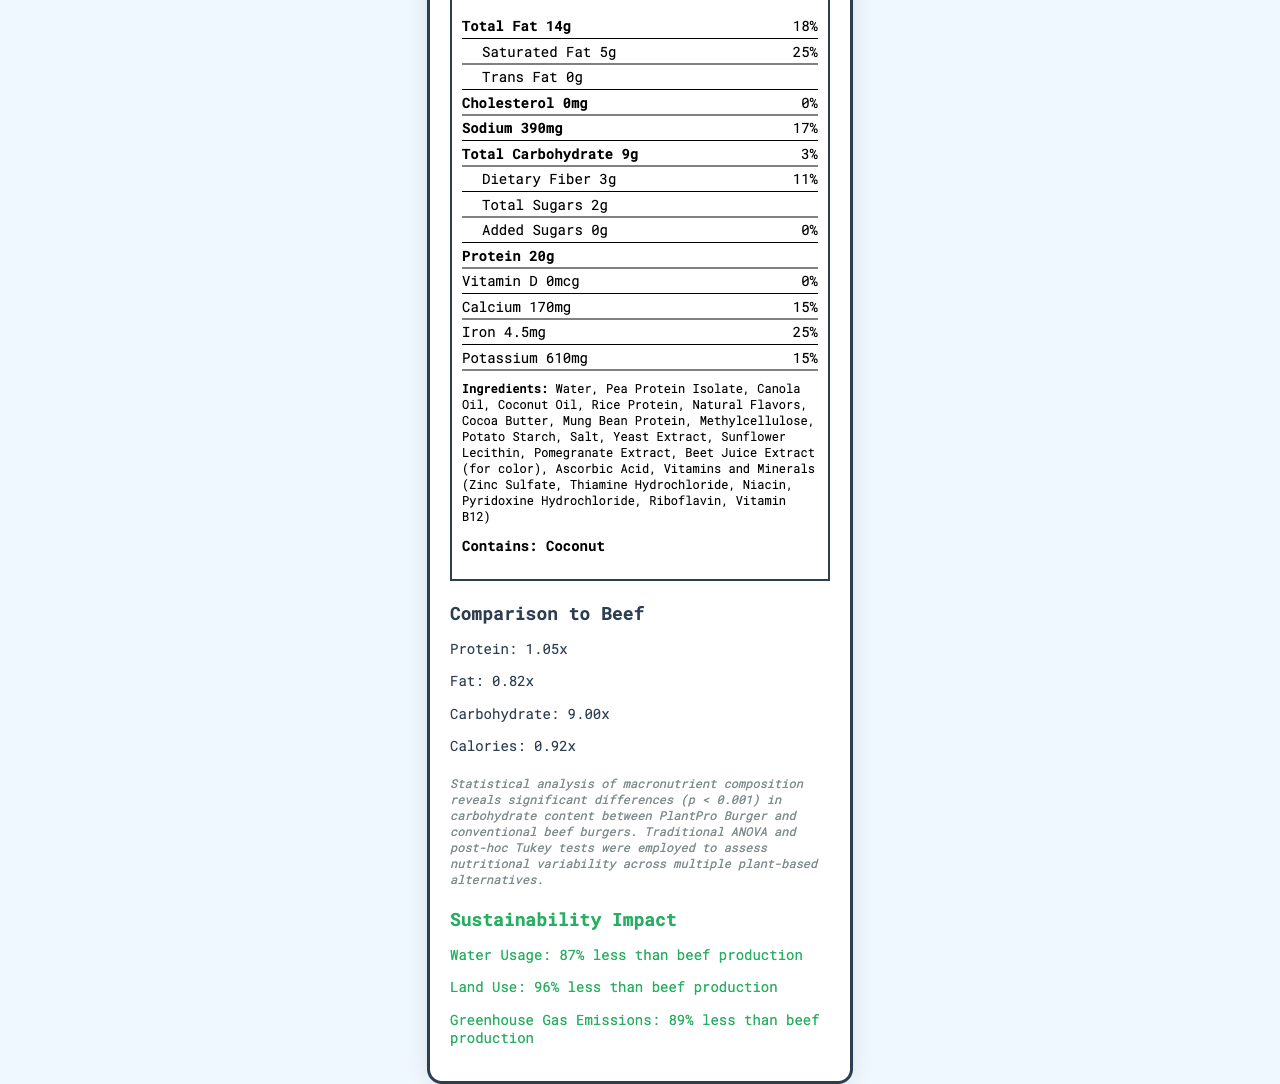how many calories are in a serving of the PlantPro Burger? The calorie content per serving is listed as "Calories 240" in the calorie information section.
Answer: 240 what is the serving size for the PlantPro Burger? The serving size is mentioned right under the product name as "Serving size 113g (1 patty)".
Answer: 113g (1 patty) how much protein does one serving of the PlantPro Burger contain? The protein content is listed in the macronutrient section as "Protein 20g."
Answer: 20g what percentage of the Daily Value is the total carbohydrate content? The daily value percentage for total carbohydrates is provided as "3%" in the nutrient information section.
Answer: 3% list all the main macronutrients provided in the nutrition label. The main macronutrients are listed in the nutrient information section: Total Fat, Saturated Fat, Trans Fat, Cholesterol, Sodium, Total Carbohydrate, Dietary Fiber, Total Sugars, Added Sugars, and Protein.
Answer: Total Fat, Saturated Fat, Trans Fat, Cholesterol, Sodium, Total Carbohydrate, Dietary Fiber, Total Sugars, Added Sugars, Protein what is the amount of iron in the PlantPro Burger? The iron content is listed as "Iron 4.5mg" in the nutrient information section.
Answer: 4.5mg The PlantPro Burger contains which of the following allergens? A. Soy B. Wheat C. Coconut D. Eggs The allergen information listed at the bottom states "Contains: Coconut."
Answer: C. Coconut how does the PlantPro Burger compare to beef in terms of carbohydrate content? A. Same B. Less C. More According to the comparison section, the carbohydrate ratio is 9.0x, indicating that the PlantPro Burger has significantly more carbohydrates than beef.
Answer: C. More what is the sustainability impact in terms of greenhouse gas emissions? A. 50% less than beef B. 70% less than beef C. 89% less than beef In the sustainability impact section, it's mentioned that greenhouse gas emissions are "89% less than beef production."
Answer: C. 89% less than beef does the PlantPro Burger contain any cholesterol? The nutrient information section indicates "Cholesterol 0mg" and "Daily Value 0%," meaning it contains no cholesterol.
Answer: No summarize the main nutritional and sustainability points presented in the document The document provides detailed nutritional facts about the PlantPro Burger, compares its macronutrient ratios to beef, and highlights its considerable sustainability impact.
Answer: The PlantPro Burger is a plant-based meat alternative with 240 calories per serving, containing 20g of protein, 14g of total fat, and 9g of total carbohydrates. It is rich in iron and has no cholesterol. The product has significant sustainability benefits, such as using 87% less water, 96% less land, and emitting 89% less greenhouse gases than conventional beef production. what method was employed in the data analysis of the macronutrient composition? The document does not provide explicit information on the statistical methods used in the data analysis, such as ANOVA or post-hoc Tukey tests.
Answer: Cannot be determined 